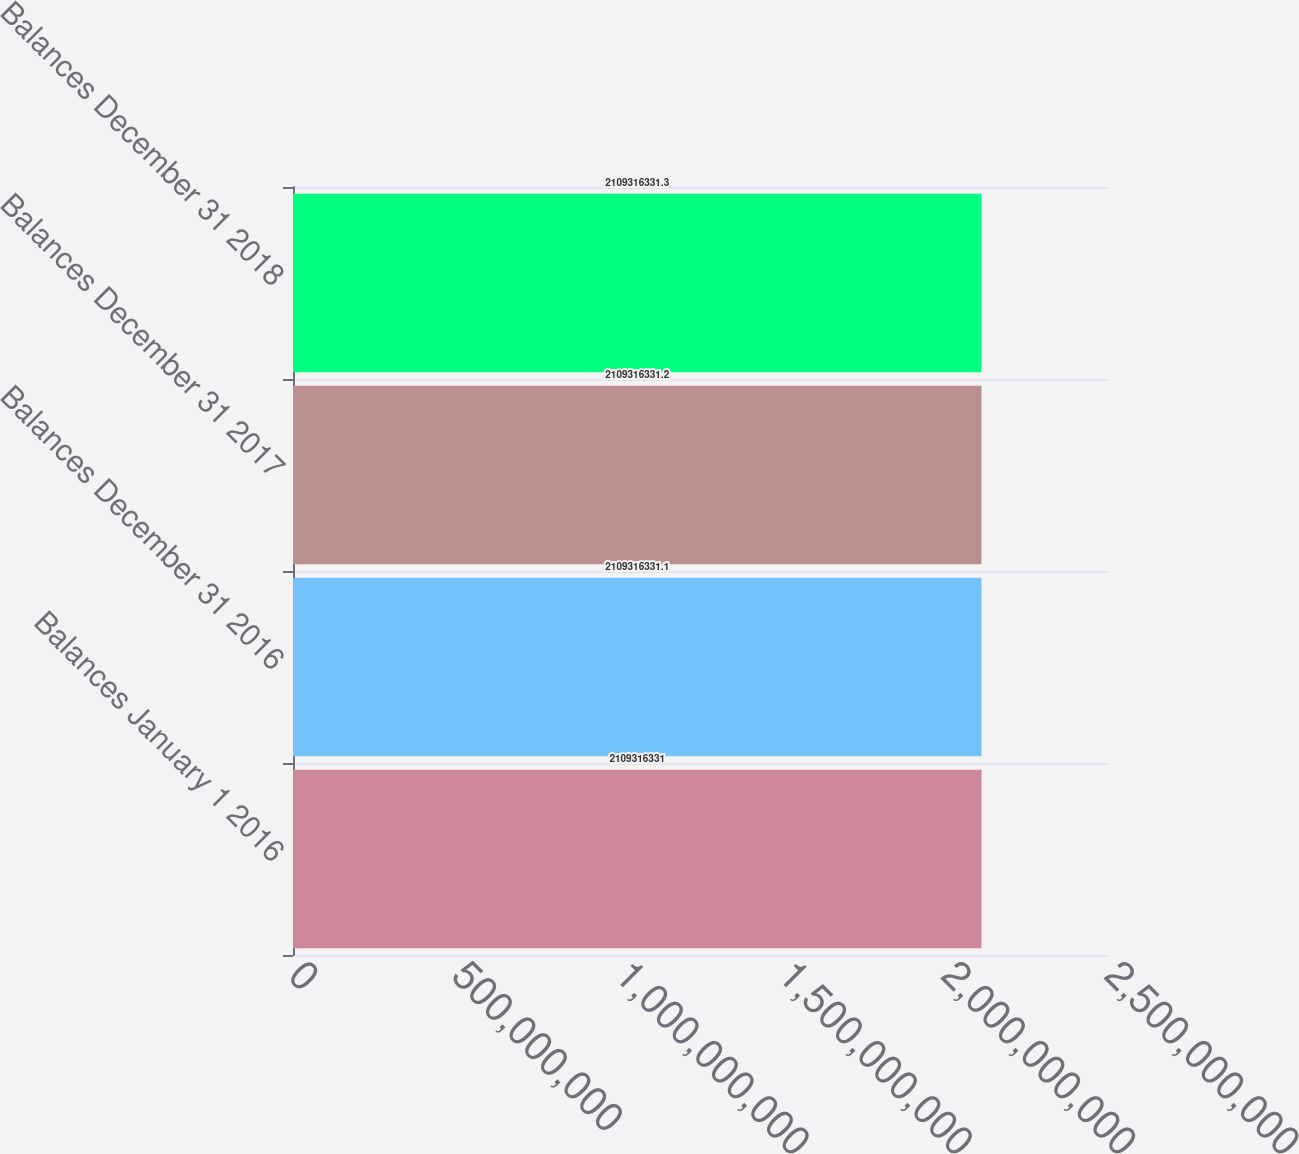<chart> <loc_0><loc_0><loc_500><loc_500><bar_chart><fcel>Balances January 1 2016<fcel>Balances December 31 2016<fcel>Balances December 31 2017<fcel>Balances December 31 2018<nl><fcel>2.10932e+09<fcel>2.10932e+09<fcel>2.10932e+09<fcel>2.10932e+09<nl></chart> 